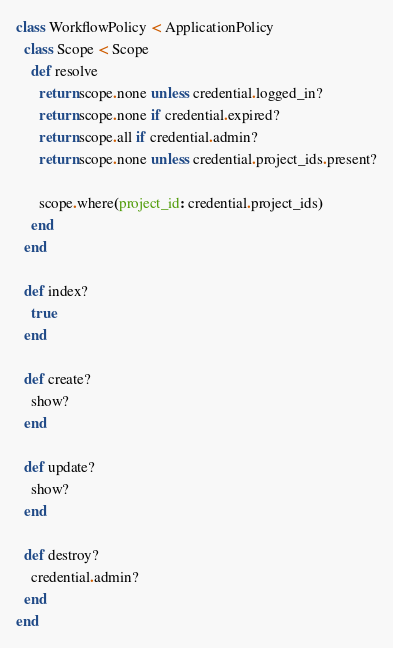Convert code to text. <code><loc_0><loc_0><loc_500><loc_500><_Ruby_>class WorkflowPolicy < ApplicationPolicy
  class Scope < Scope
    def resolve
      return scope.none unless credential.logged_in?
      return scope.none if credential.expired?
      return scope.all if credential.admin?
      return scope.none unless credential.project_ids.present?

      scope.where(project_id: credential.project_ids)
    end
  end

  def index?
    true
  end

  def create?
    show?
  end

  def update?
    show?
  end

  def destroy?
    credential.admin?
  end
end
</code> 